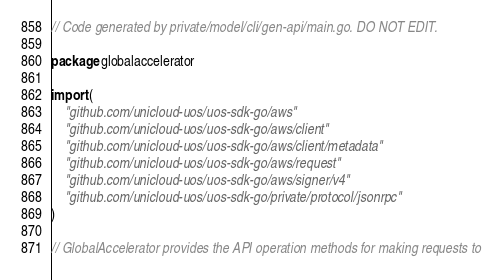Convert code to text. <code><loc_0><loc_0><loc_500><loc_500><_Go_>// Code generated by private/model/cli/gen-api/main.go. DO NOT EDIT.

package globalaccelerator

import (
	"github.com/unicloud-uos/uos-sdk-go/aws"
	"github.com/unicloud-uos/uos-sdk-go/aws/client"
	"github.com/unicloud-uos/uos-sdk-go/aws/client/metadata"
	"github.com/unicloud-uos/uos-sdk-go/aws/request"
	"github.com/unicloud-uos/uos-sdk-go/aws/signer/v4"
	"github.com/unicloud-uos/uos-sdk-go/private/protocol/jsonrpc"
)

// GlobalAccelerator provides the API operation methods for making requests to</code> 